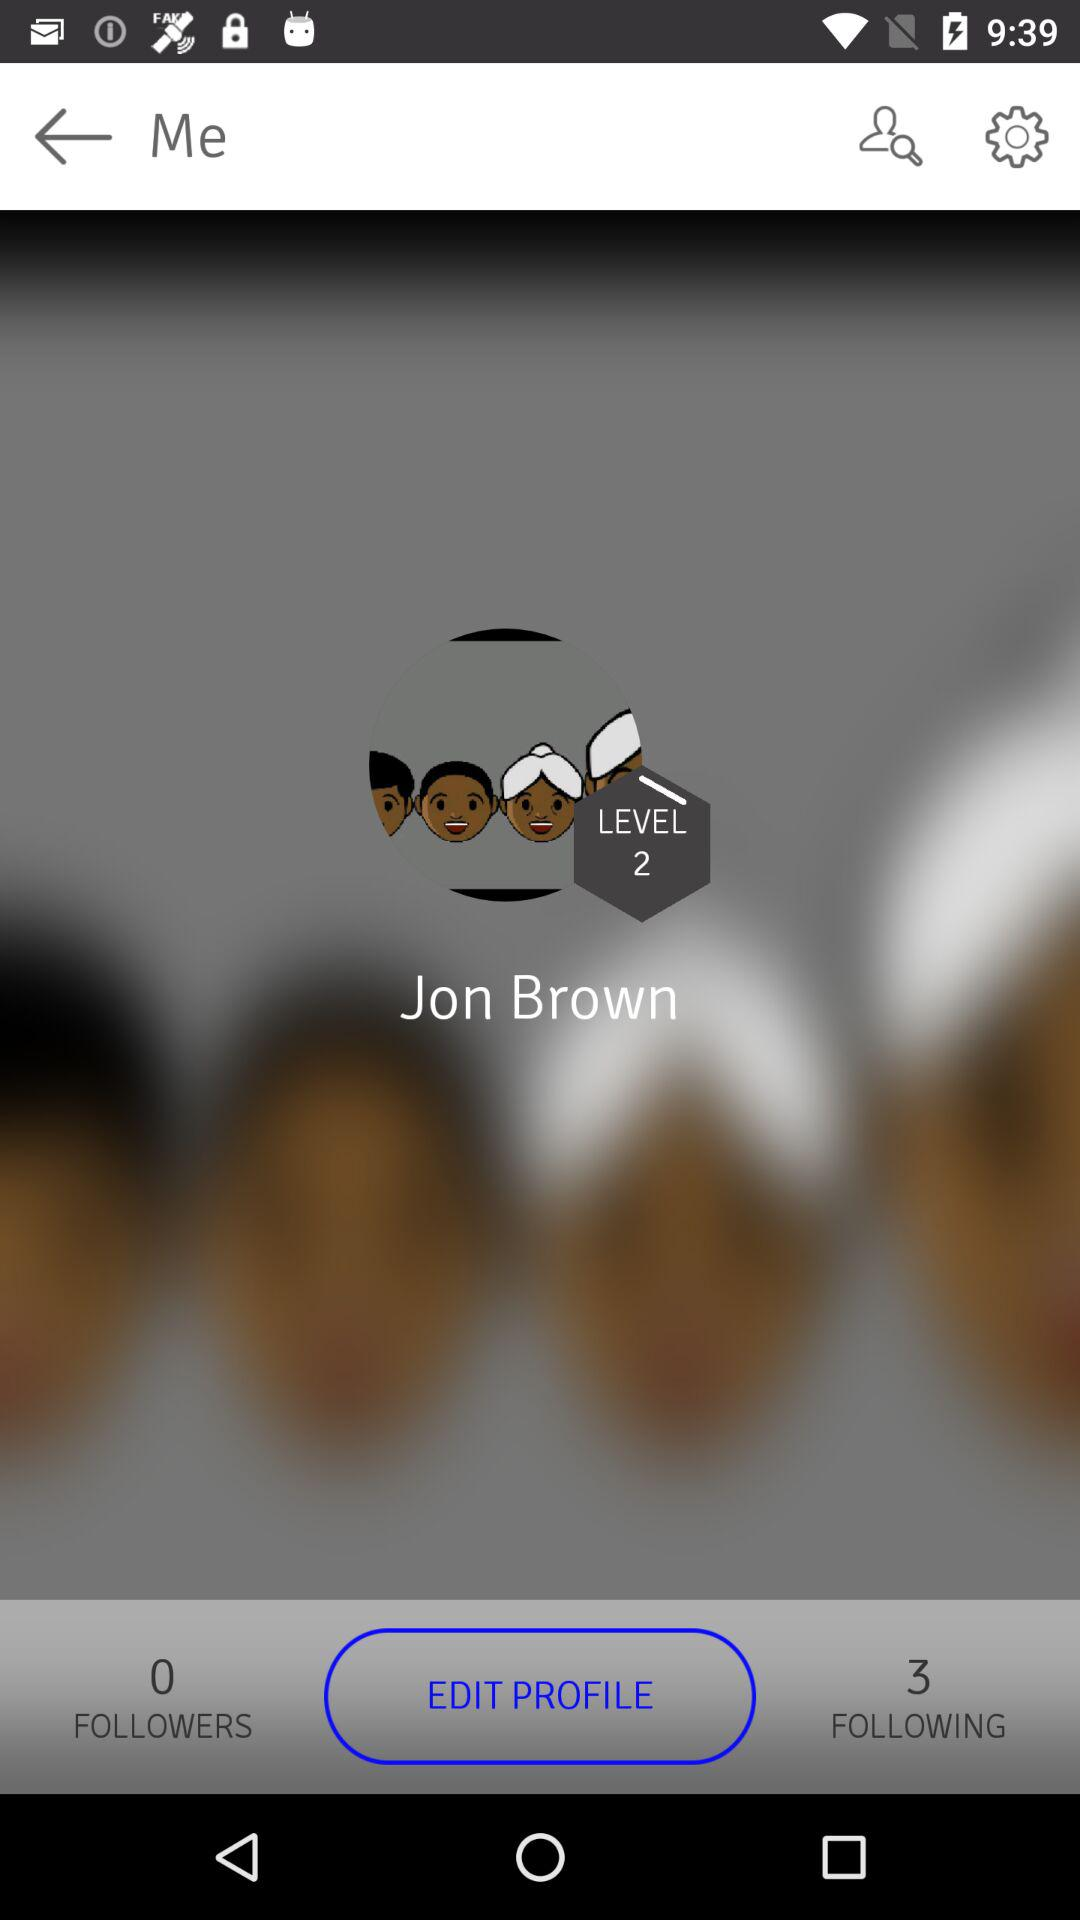How many levels has Jon Brown achieved?
Answer the question using a single word or phrase. 2 